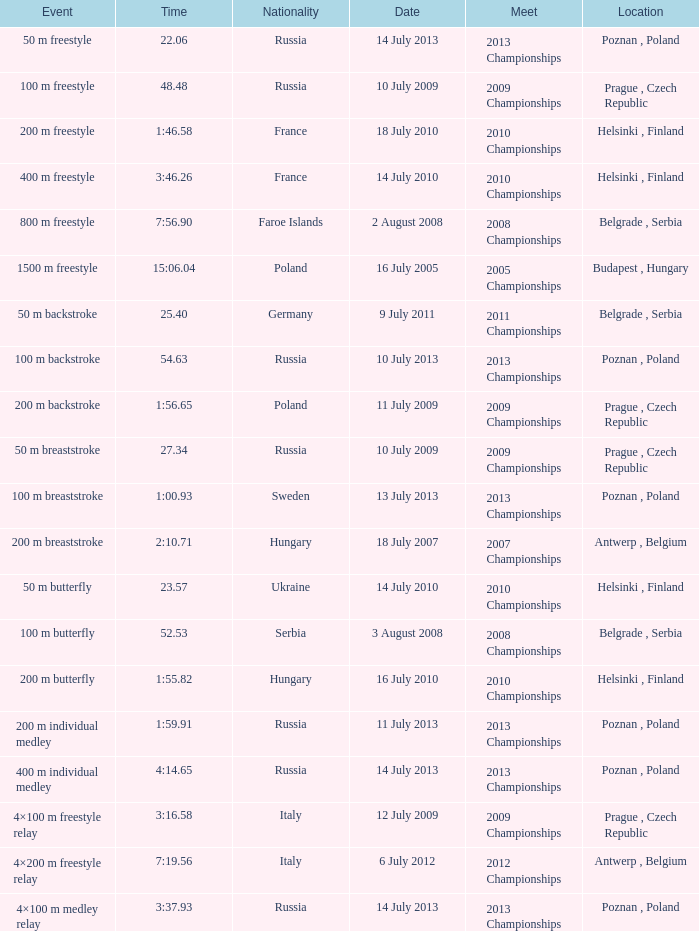90 conducted? Belgrade , Serbia. 